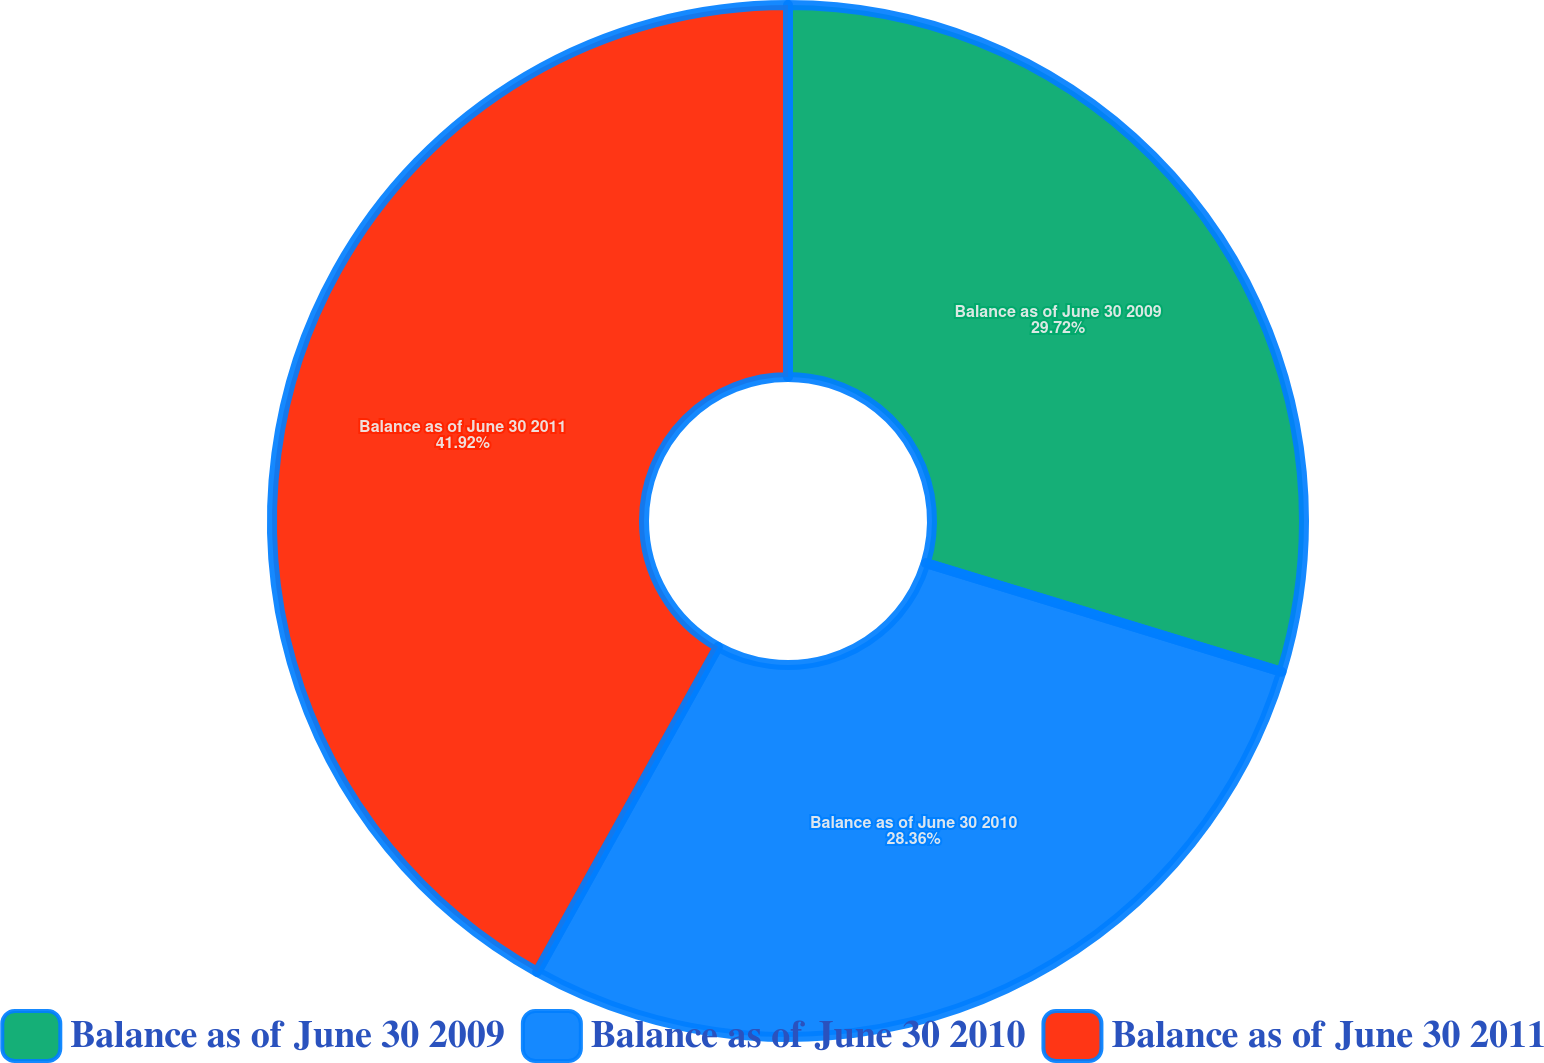Convert chart. <chart><loc_0><loc_0><loc_500><loc_500><pie_chart><fcel>Balance as of June 30 2009<fcel>Balance as of June 30 2010<fcel>Balance as of June 30 2011<nl><fcel>29.72%<fcel>28.36%<fcel>41.92%<nl></chart> 